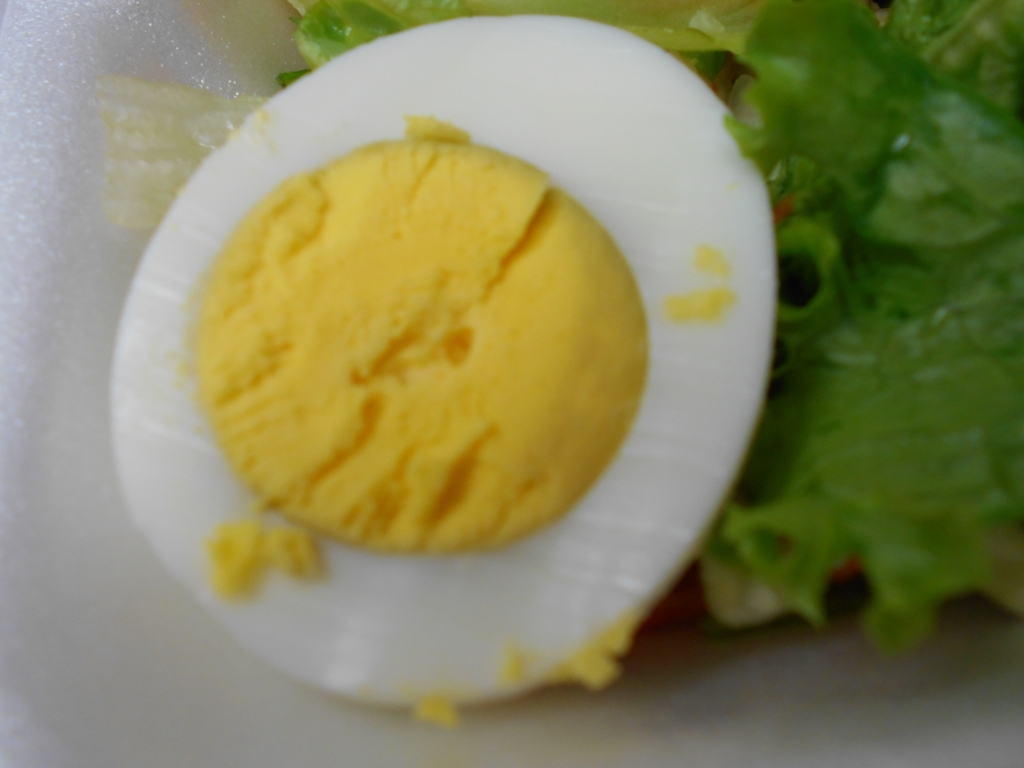Can you tell if the egg in the salad is fresh? While it's difficult to ascertain the freshness of the egg just from the image, a fresh egg usually has a firm yolk and clear, solid whites. This egg's yolk seems to have a rich color, which can be indicative of freshness, but this is not conclusive without additional information. How can someone ensure that their eggs are fresh when preparing a dish? To ensure the freshness of eggs, one should purchase them before the sell-by date, store them properly in the fridge, and consider doing a float test in water – fresh eggs will sink to the bottom while older ones will float. 